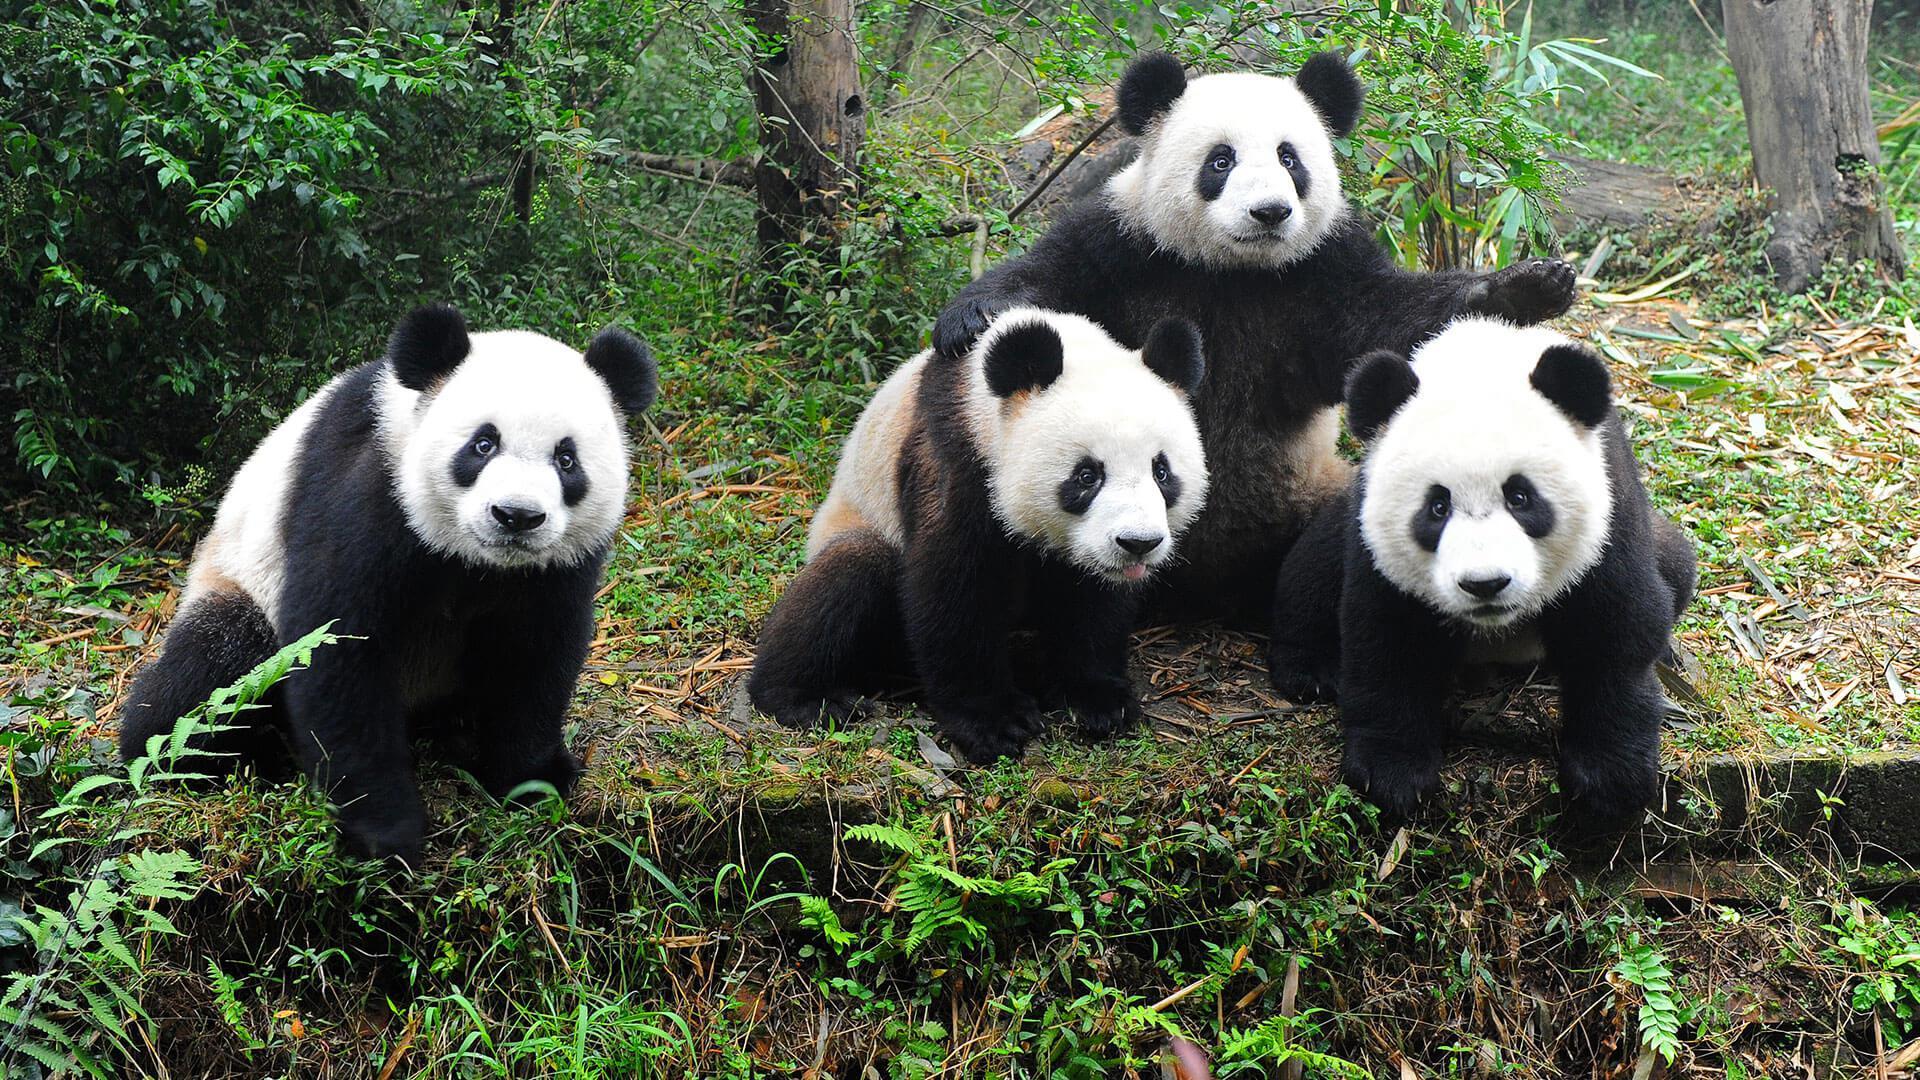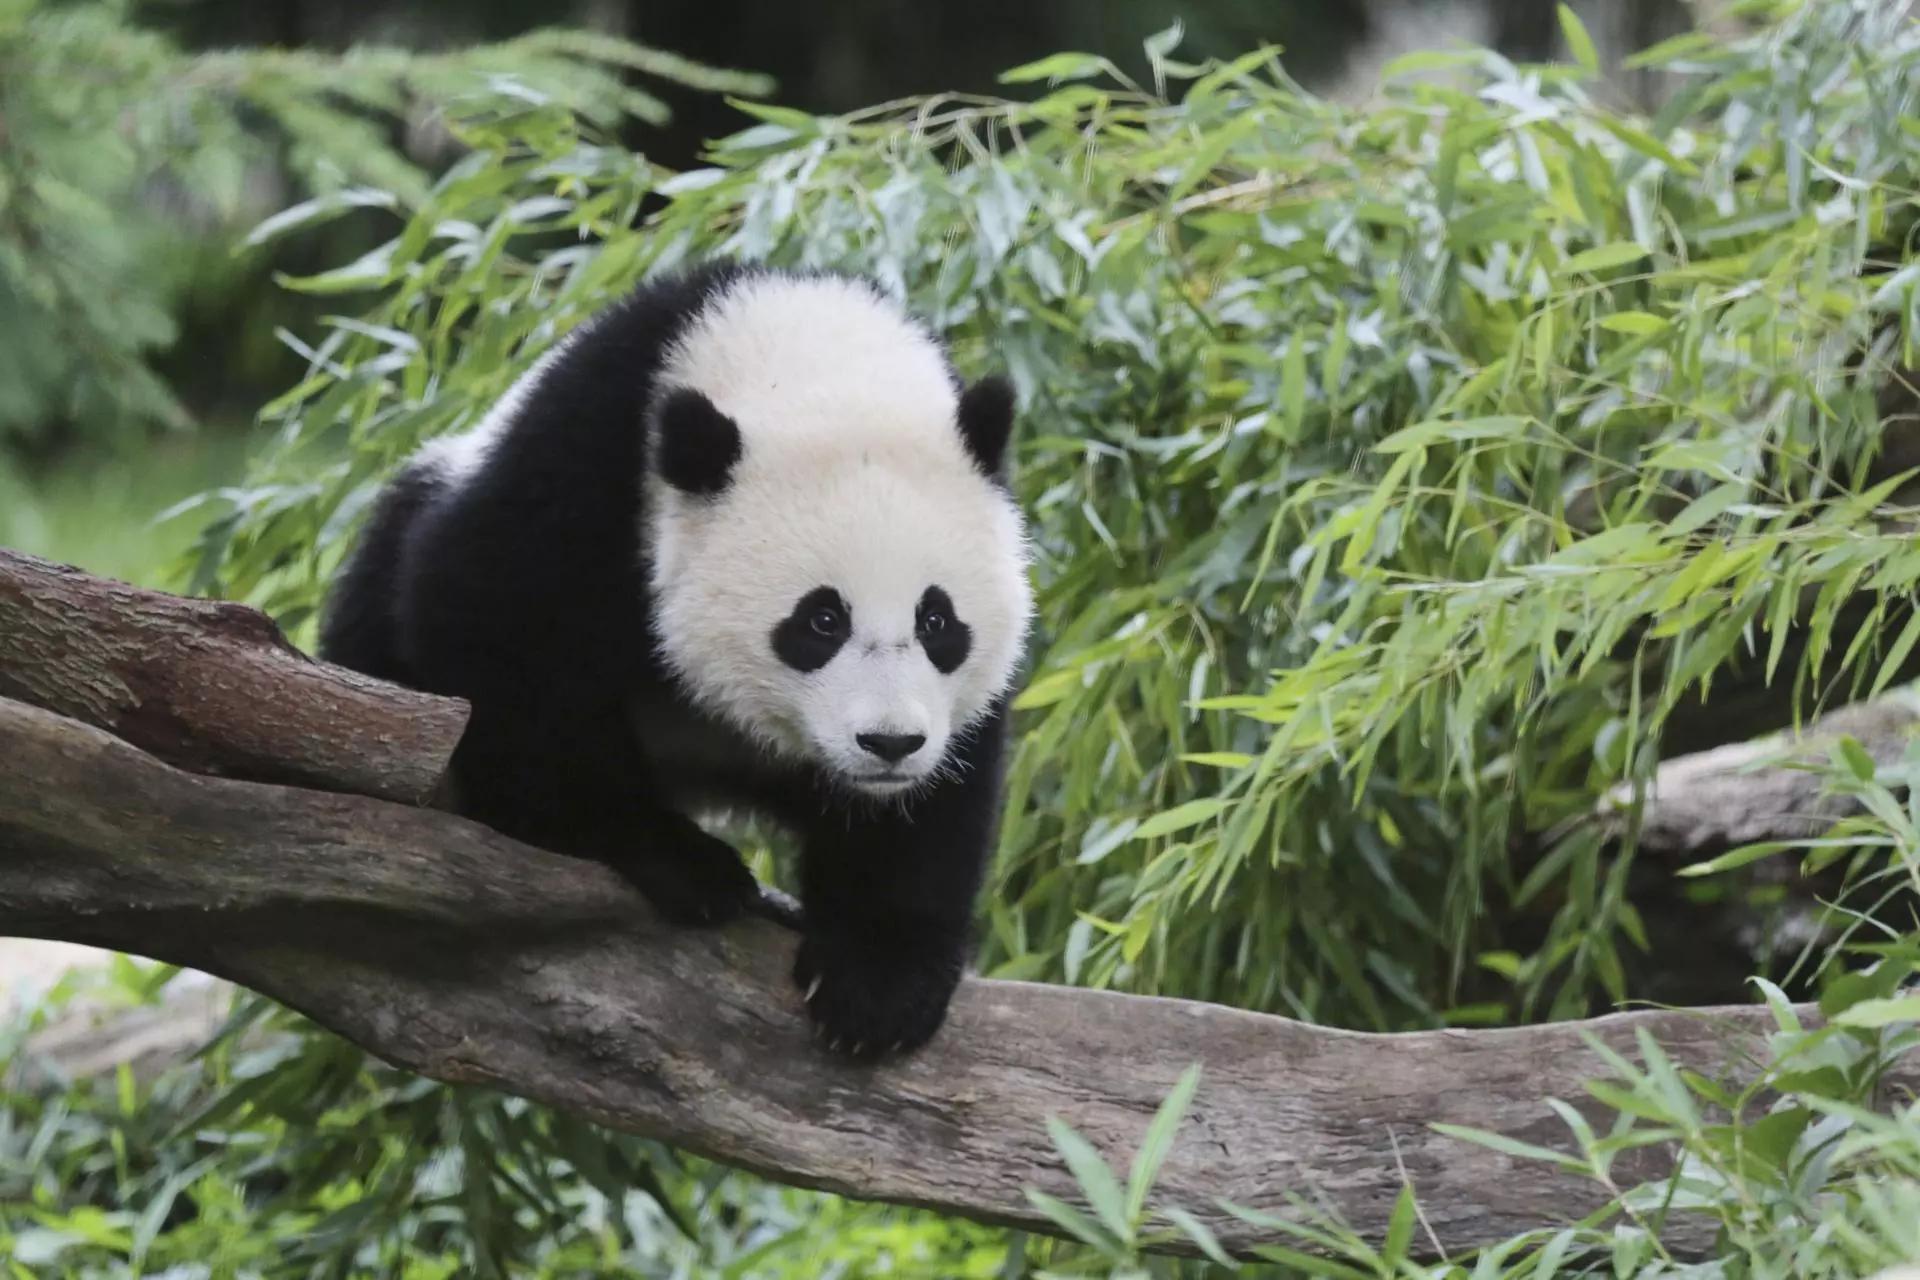The first image is the image on the left, the second image is the image on the right. Assess this claim about the two images: "Six pandas are sitting outside.". Correct or not? Answer yes or no. No. The first image is the image on the left, the second image is the image on the right. For the images displayed, is the sentence "There is no more than one panda in the right image." factually correct? Answer yes or no. Yes. 